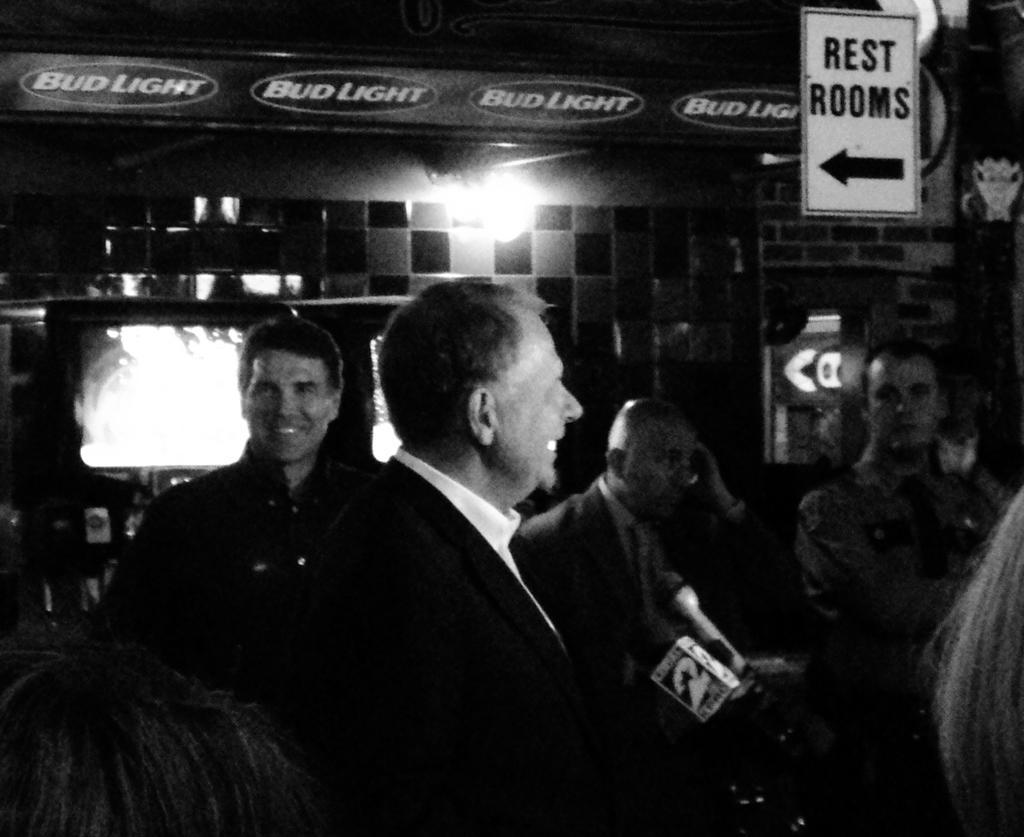How would you summarize this image in a sentence or two? At the bottom of the image few people are standing and smiling. Behind them there is a wall, on the wall there is a banner and sign board. 